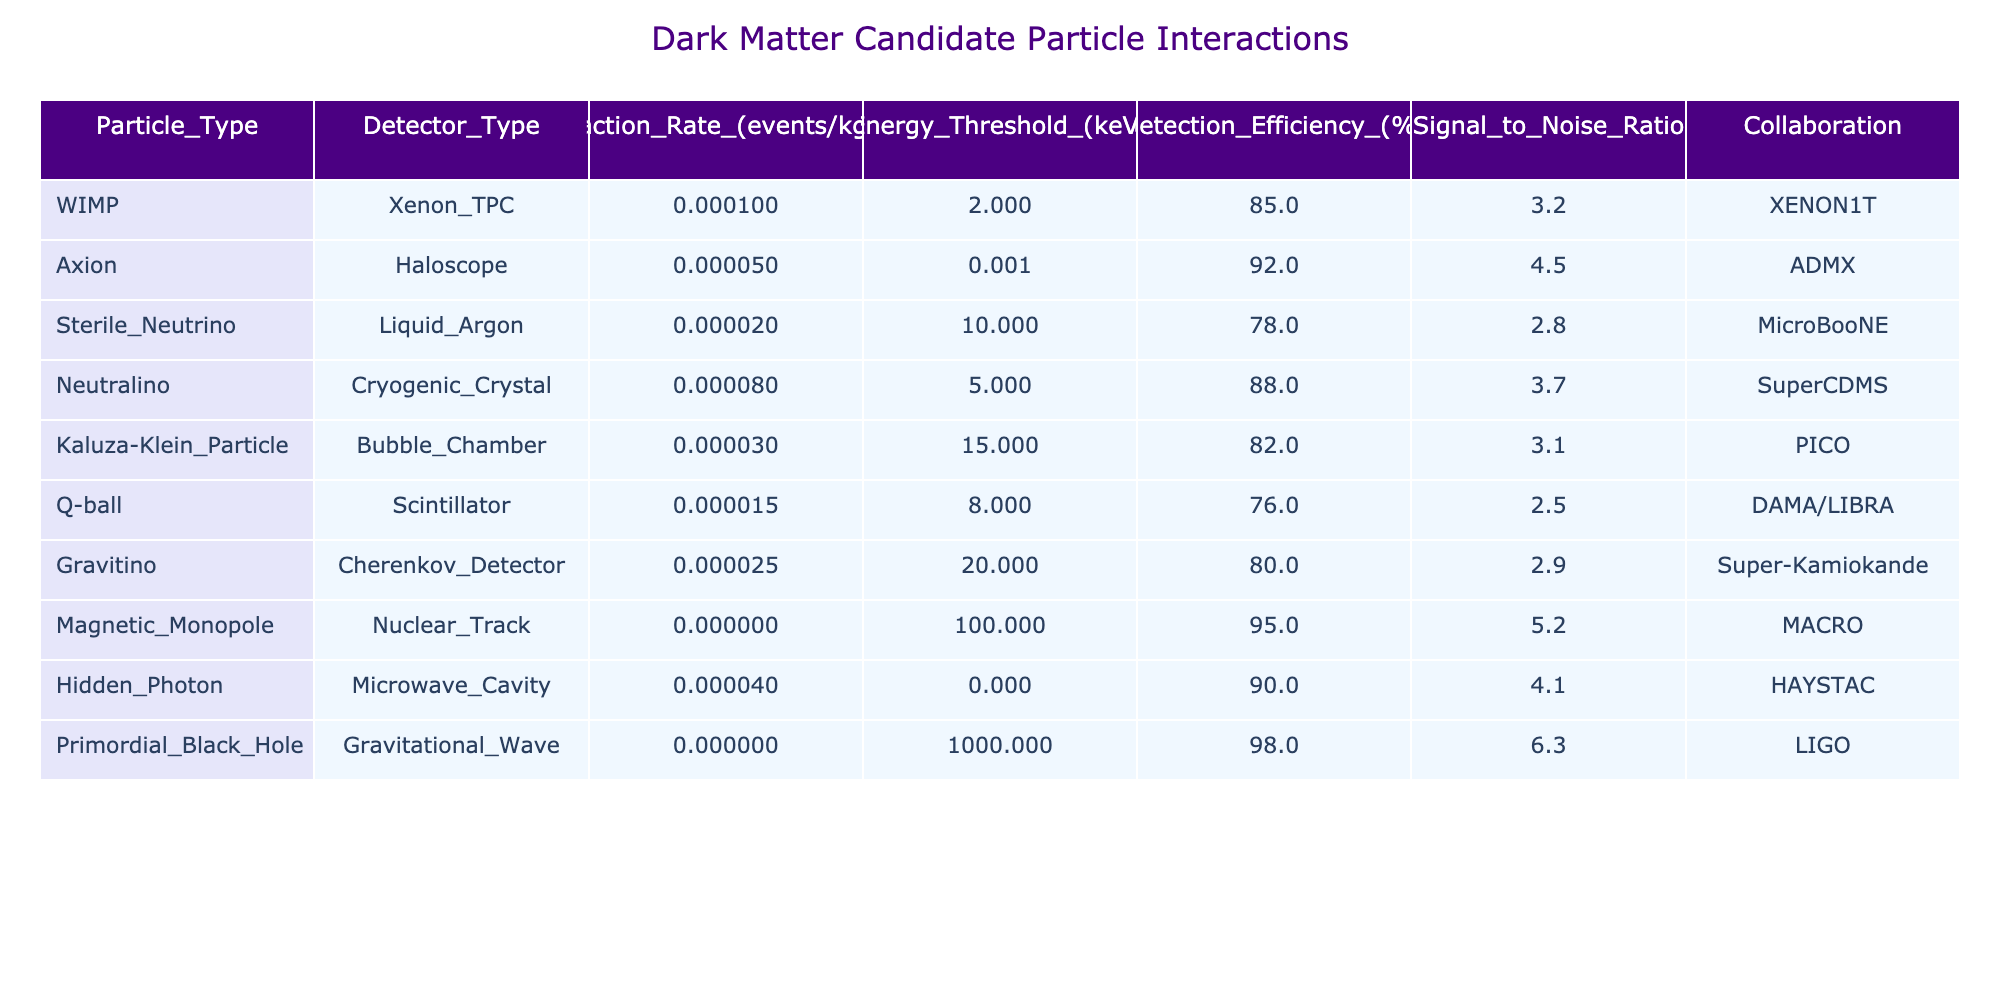What is the interaction rate for WIMP in Xenon TPC? The interaction rate for WIMP in the Xenon TPC detector is provided directly in the table under the "Interaction Rate_(events/kg/day)" column for the WIMP row. It shows 0.0001 events/kg/day.
Answer: 0.0001 Which particle type has the highest detection efficiency? By checking the "Detection Efficiency (%)" column for all particle types, we can see that the Magnetic Monopole has the highest efficiency at 95%.
Answer: Magnetic Monopole Calculate the average energy threshold for all detected particles. First, we extract the energy thresholds from the "Energy_Threshold_(keV)" column: 2, 0.001, 10, 5, 15, 8, 20, 100, 0.0001, 1000. Then we calculate the average: (2 + 0.001 + 10 + 5 + 15 + 8 + 20 + 100 + 0.0001 + 1000) / 10 = 116.10001 / 10 = 116.10001.
Answer: 116.1 Is the interaction rate for the Primordial Black Hole greater than that of the WIMP? Looking at the "Interaction Rate_(events/kg/day)" column, the Primordial Black Hole has a rate of 0.0000001, while the WIMP has a rate of 0.0001. Since 0.0000001 is less than 0.0001, the statement is false.
Answer: No Which collaboration has a particle with the highest Signal to Noise Ratio? To identify the highest Signal to Noise Ratio, we need to look at the "Signal to Noise Ratio" column. The highest value is 6.3 for the Primordial Black Hole associated with LIGO, which is greater than all other ratios.
Answer: LIGO How much higher is the detection efficiency of the Axion compared to the Q-ball? We first check the detection efficiencies: The Axion has an efficiency of 92%, and the Q-ball has 76%. To find the difference: 92 - 76 = 16%. The Axion's detection efficiency is higher by 16%.
Answer: 16% Do any of the particles have an interaction rate greater than 0.0001? Looking through the "Interaction Rate_(events/kg/day)" column, we find that all values are either less than or equal to 0.0001, and the maximum value is 0.0001 for WIMP. Thus, no particle has a rate greater than 0.0001.
Answer: No What is the total interaction rate of all particles combined? We need to sum the interaction rates for all particles from the "Interaction Rate_(events/kg/day)" column: 0.0001 + 0.00005 + 0.00002 + 0.00008 + 0.00003 + 0.000015 + 0.000025 + 0.0000005 + 0.00004 + 0.0000001 = 0.00025365. It gives us a combined rate of 0.00025365 events/kg/day.
Answer: 0.00025365 Which particle type has the lowest interaction rate? The lowest interaction rate can be found by examining the "Interaction Rate_(events/kg/day)" column. The Magnetic Monopole has the lowest rate at 0.0000005 events/kg/day.
Answer: Magnetic Monopole Is there a particle with a detection efficiency less than 80%? To answer this, we can look at the "Detection Efficiency (%)" column. The Q-ball has a detection efficiency of 76%, which is indeed less than 80%. Therefore, there is at least one particle with low efficiency.
Answer: Yes 